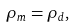<formula> <loc_0><loc_0><loc_500><loc_500>\rho _ { m } = \rho _ { d } ,</formula> 